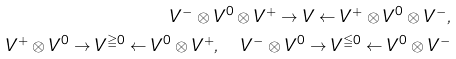<formula> <loc_0><loc_0><loc_500><loc_500>V ^ { - } \otimes V ^ { 0 } \otimes V ^ { + } \to V \gets V ^ { + } \otimes V ^ { 0 } \otimes V ^ { - } , \\ V ^ { + } \otimes V ^ { 0 } \to V ^ { \geqq 0 } \gets V ^ { 0 } \otimes V ^ { + } , \quad V ^ { - } \otimes V ^ { 0 } \to V ^ { \leqq 0 } \gets V ^ { 0 } \otimes V ^ { - }</formula> 